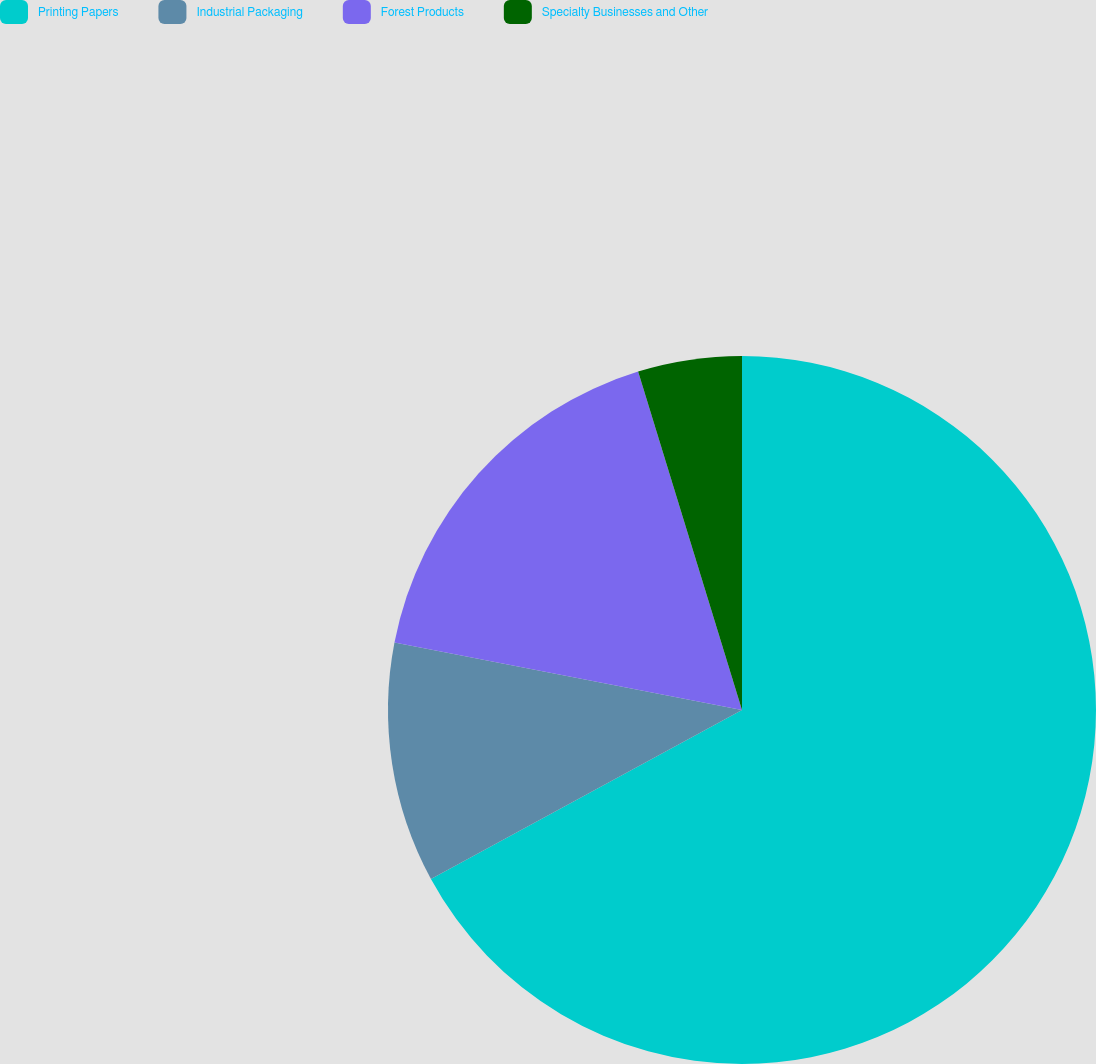<chart> <loc_0><loc_0><loc_500><loc_500><pie_chart><fcel>Printing Papers<fcel>Industrial Packaging<fcel>Forest Products<fcel>Specialty Businesses and Other<nl><fcel>67.08%<fcel>10.97%<fcel>17.21%<fcel>4.74%<nl></chart> 